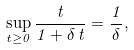Convert formula to latex. <formula><loc_0><loc_0><loc_500><loc_500>\sup _ { t \geq 0 } \frac { t } { 1 + \delta \, t } = \frac { 1 } { \delta } ,</formula> 